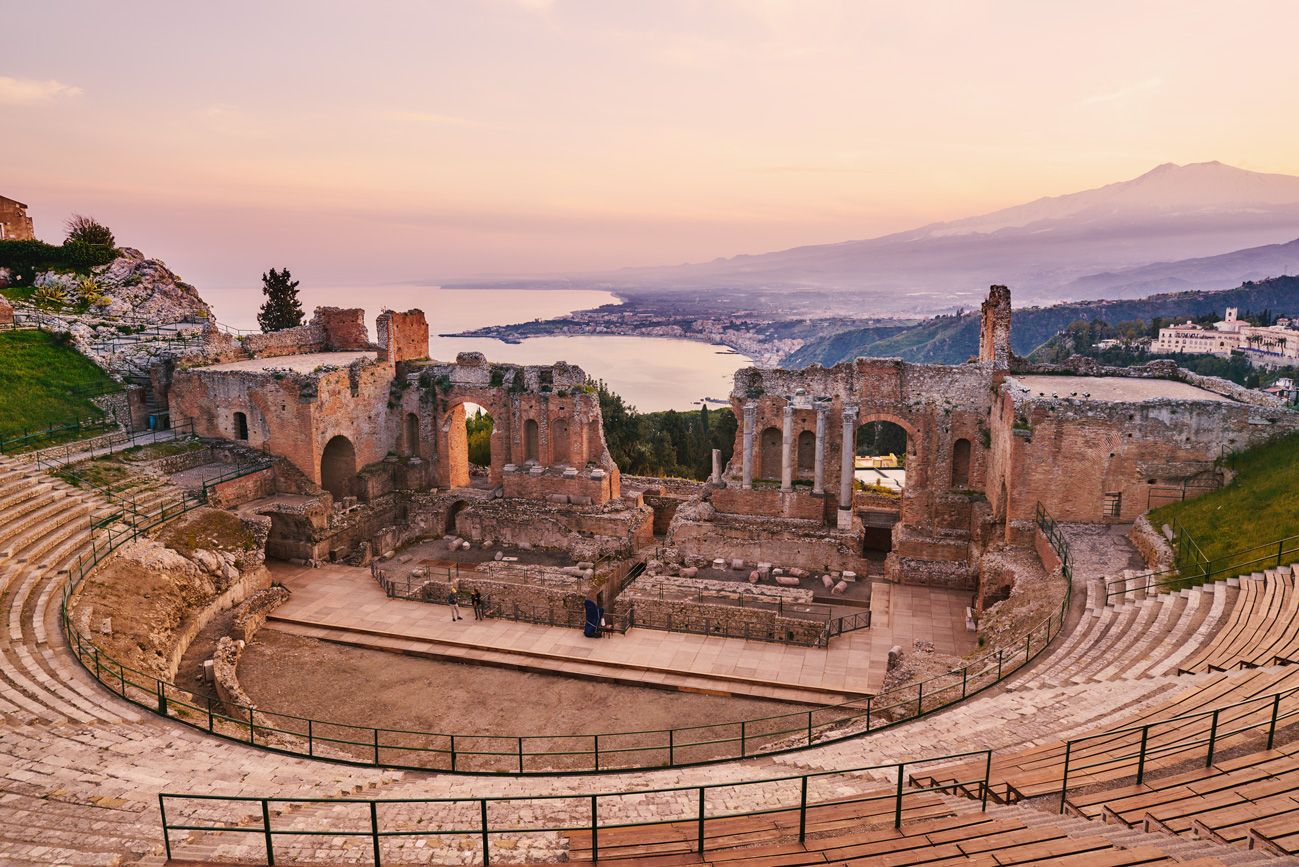What can you say about the architectural style of this theater? The theater is an excellent example of ancient Greek architecture, adapted later by the Romans. Its construction follows the classic Hellenistic style with tiers of seats arranged in a semicircular pattern around the orchestra, which is the flat area where the chorus would dance and sing. The use of local stone and the integration into the natural landscape are typical of Greek theaters. The Romans added their touches such as the stage backdrop and the use of brick and concrete, which allowed for more elaborate scenes and decorations. 